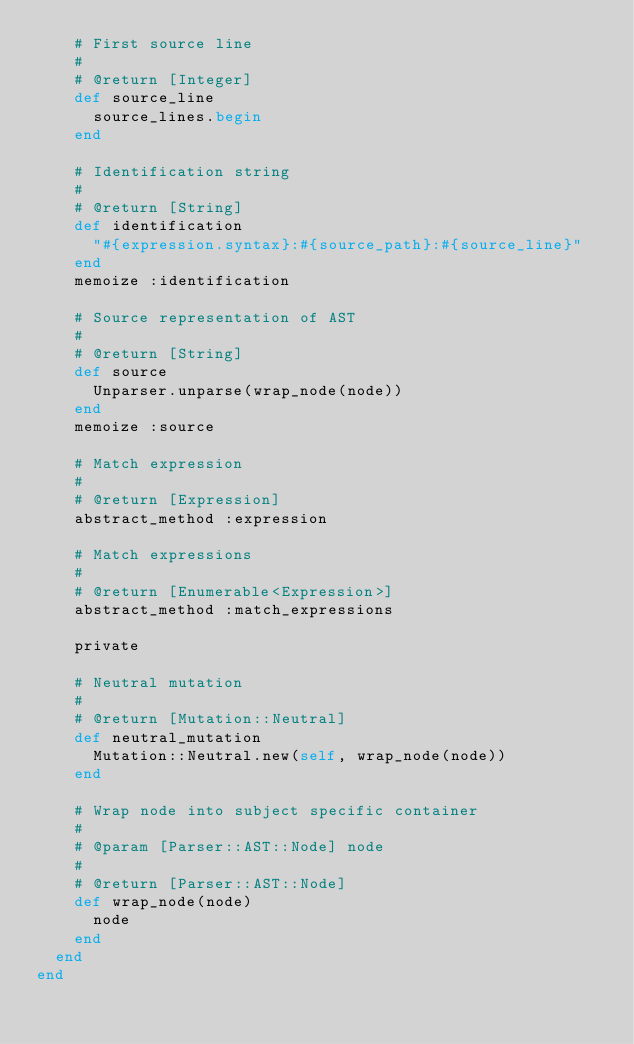Convert code to text. <code><loc_0><loc_0><loc_500><loc_500><_Ruby_>    # First source line
    #
    # @return [Integer]
    def source_line
      source_lines.begin
    end

    # Identification string
    #
    # @return [String]
    def identification
      "#{expression.syntax}:#{source_path}:#{source_line}"
    end
    memoize :identification

    # Source representation of AST
    #
    # @return [String]
    def source
      Unparser.unparse(wrap_node(node))
    end
    memoize :source

    # Match expression
    #
    # @return [Expression]
    abstract_method :expression

    # Match expressions
    #
    # @return [Enumerable<Expression>]
    abstract_method :match_expressions

    private

    # Neutral mutation
    #
    # @return [Mutation::Neutral]
    def neutral_mutation
      Mutation::Neutral.new(self, wrap_node(node))
    end

    # Wrap node into subject specific container
    #
    # @param [Parser::AST::Node] node
    #
    # @return [Parser::AST::Node]
    def wrap_node(node)
      node
    end
  end
end
</code> 